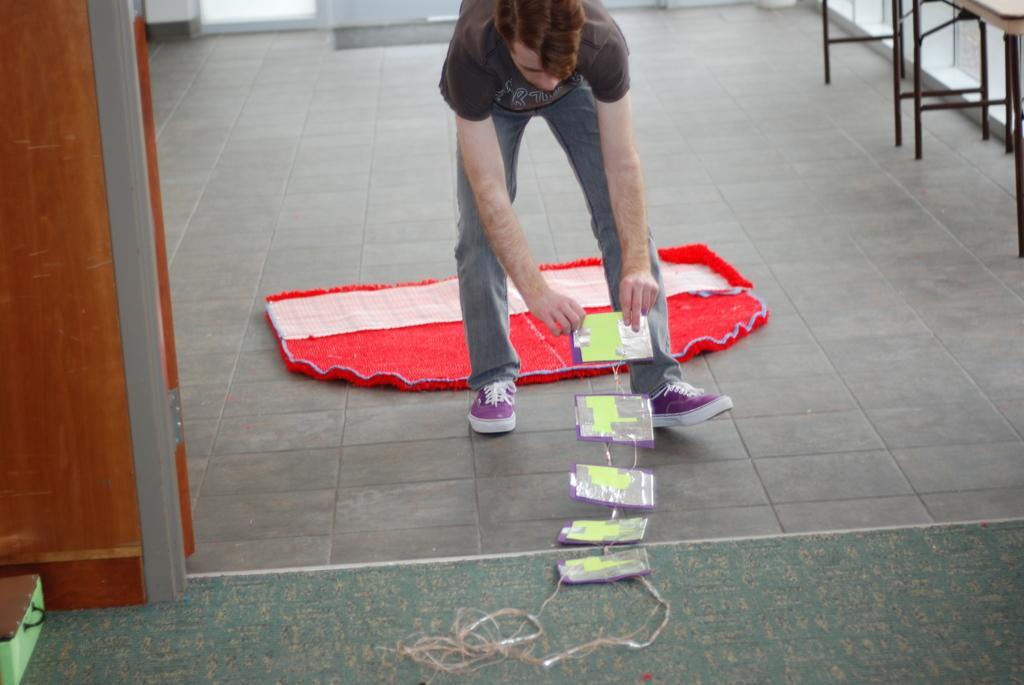Describe this image in one or two sentences. Here I can see a person bending and holding a cardboard which is attached to a thread. At the back of him there is a red color mat on the floor. At the top right-hand corner there are two tables. On the left side there is a wooden plank and also a box placed on the floor. 